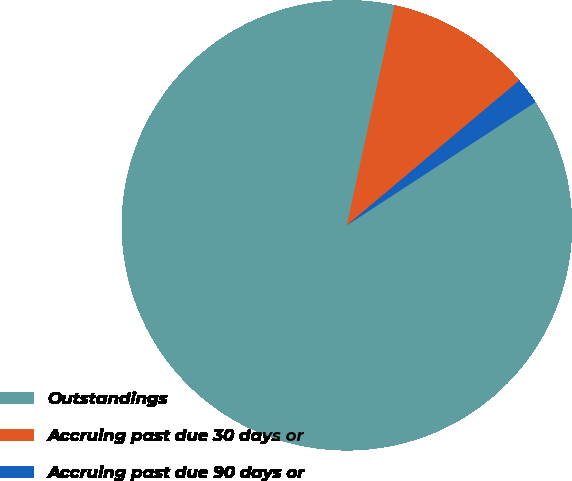Convert chart. <chart><loc_0><loc_0><loc_500><loc_500><pie_chart><fcel>Outstandings<fcel>Accruing past due 30 days or<fcel>Accruing past due 90 days or<nl><fcel>87.61%<fcel>10.48%<fcel>1.91%<nl></chart> 